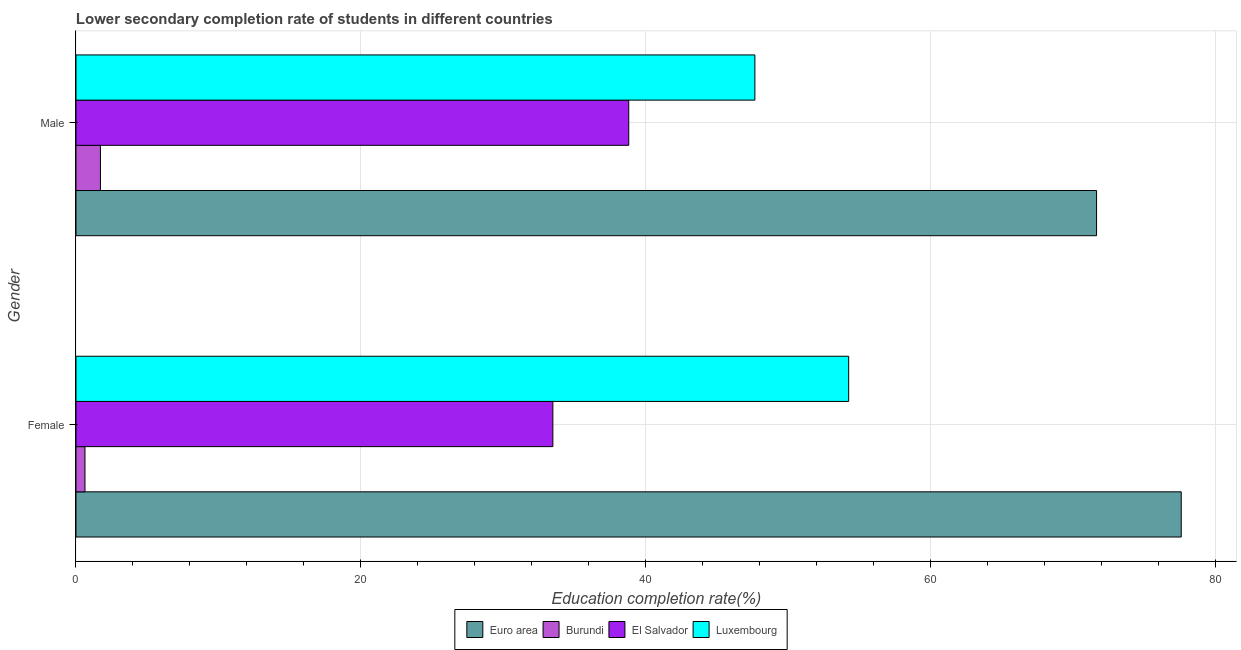How many different coloured bars are there?
Keep it short and to the point. 4. How many groups of bars are there?
Ensure brevity in your answer.  2. Are the number of bars on each tick of the Y-axis equal?
Your answer should be very brief. Yes. How many bars are there on the 2nd tick from the top?
Your answer should be very brief. 4. How many bars are there on the 2nd tick from the bottom?
Your answer should be compact. 4. What is the label of the 1st group of bars from the top?
Offer a terse response. Male. What is the education completion rate of male students in Burundi?
Ensure brevity in your answer.  1.72. Across all countries, what is the maximum education completion rate of male students?
Provide a succinct answer. 71.68. Across all countries, what is the minimum education completion rate of male students?
Offer a terse response. 1.72. In which country was the education completion rate of male students maximum?
Offer a terse response. Euro area. In which country was the education completion rate of male students minimum?
Your response must be concise. Burundi. What is the total education completion rate of male students in the graph?
Offer a terse response. 159.9. What is the difference between the education completion rate of male students in Burundi and that in Luxembourg?
Offer a very short reply. -45.96. What is the difference between the education completion rate of female students in Luxembourg and the education completion rate of male students in Burundi?
Provide a short and direct response. 52.55. What is the average education completion rate of male students per country?
Keep it short and to the point. 39.97. What is the difference between the education completion rate of male students and education completion rate of female students in Euro area?
Make the answer very short. -5.95. In how many countries, is the education completion rate of male students greater than 60 %?
Your response must be concise. 1. What is the ratio of the education completion rate of male students in Luxembourg to that in Euro area?
Your response must be concise. 0.67. What does the 1st bar from the bottom in Female represents?
Make the answer very short. Euro area. Are all the bars in the graph horizontal?
Provide a short and direct response. Yes. Does the graph contain any zero values?
Offer a very short reply. No. Where does the legend appear in the graph?
Ensure brevity in your answer.  Bottom center. What is the title of the graph?
Give a very brief answer. Lower secondary completion rate of students in different countries. What is the label or title of the X-axis?
Offer a very short reply. Education completion rate(%). What is the label or title of the Y-axis?
Provide a short and direct response. Gender. What is the Education completion rate(%) in Euro area in Female?
Provide a short and direct response. 77.63. What is the Education completion rate(%) of Burundi in Female?
Your answer should be compact. 0.63. What is the Education completion rate(%) in El Salvador in Female?
Your answer should be compact. 33.49. What is the Education completion rate(%) in Luxembourg in Female?
Keep it short and to the point. 54.27. What is the Education completion rate(%) of Euro area in Male?
Keep it short and to the point. 71.68. What is the Education completion rate(%) in Burundi in Male?
Provide a succinct answer. 1.72. What is the Education completion rate(%) of El Salvador in Male?
Ensure brevity in your answer.  38.82. What is the Education completion rate(%) of Luxembourg in Male?
Your answer should be compact. 47.68. Across all Gender, what is the maximum Education completion rate(%) of Euro area?
Your answer should be very brief. 77.63. Across all Gender, what is the maximum Education completion rate(%) of Burundi?
Your response must be concise. 1.72. Across all Gender, what is the maximum Education completion rate(%) of El Salvador?
Your answer should be compact. 38.82. Across all Gender, what is the maximum Education completion rate(%) of Luxembourg?
Your answer should be very brief. 54.27. Across all Gender, what is the minimum Education completion rate(%) in Euro area?
Provide a short and direct response. 71.68. Across all Gender, what is the minimum Education completion rate(%) in Burundi?
Provide a short and direct response. 0.63. Across all Gender, what is the minimum Education completion rate(%) of El Salvador?
Make the answer very short. 33.49. Across all Gender, what is the minimum Education completion rate(%) of Luxembourg?
Your response must be concise. 47.68. What is the total Education completion rate(%) in Euro area in the graph?
Your answer should be compact. 149.3. What is the total Education completion rate(%) in Burundi in the graph?
Provide a short and direct response. 2.35. What is the total Education completion rate(%) of El Salvador in the graph?
Give a very brief answer. 72.32. What is the total Education completion rate(%) of Luxembourg in the graph?
Keep it short and to the point. 101.95. What is the difference between the Education completion rate(%) of Euro area in Female and that in Male?
Ensure brevity in your answer.  5.95. What is the difference between the Education completion rate(%) of Burundi in Female and that in Male?
Your answer should be very brief. -1.09. What is the difference between the Education completion rate(%) of El Salvador in Female and that in Male?
Your answer should be very brief. -5.33. What is the difference between the Education completion rate(%) in Luxembourg in Female and that in Male?
Make the answer very short. 6.59. What is the difference between the Education completion rate(%) of Euro area in Female and the Education completion rate(%) of Burundi in Male?
Ensure brevity in your answer.  75.91. What is the difference between the Education completion rate(%) of Euro area in Female and the Education completion rate(%) of El Salvador in Male?
Offer a very short reply. 38.8. What is the difference between the Education completion rate(%) of Euro area in Female and the Education completion rate(%) of Luxembourg in Male?
Your answer should be very brief. 29.94. What is the difference between the Education completion rate(%) in Burundi in Female and the Education completion rate(%) in El Salvador in Male?
Offer a terse response. -38.19. What is the difference between the Education completion rate(%) in Burundi in Female and the Education completion rate(%) in Luxembourg in Male?
Make the answer very short. -47.05. What is the difference between the Education completion rate(%) in El Salvador in Female and the Education completion rate(%) in Luxembourg in Male?
Provide a short and direct response. -14.19. What is the average Education completion rate(%) of Euro area per Gender?
Make the answer very short. 74.65. What is the average Education completion rate(%) in Burundi per Gender?
Keep it short and to the point. 1.17. What is the average Education completion rate(%) in El Salvador per Gender?
Your answer should be compact. 36.16. What is the average Education completion rate(%) in Luxembourg per Gender?
Your answer should be compact. 50.97. What is the difference between the Education completion rate(%) in Euro area and Education completion rate(%) in Burundi in Female?
Keep it short and to the point. 76.99. What is the difference between the Education completion rate(%) in Euro area and Education completion rate(%) in El Salvador in Female?
Your answer should be very brief. 44.13. What is the difference between the Education completion rate(%) in Euro area and Education completion rate(%) in Luxembourg in Female?
Offer a terse response. 23.36. What is the difference between the Education completion rate(%) in Burundi and Education completion rate(%) in El Salvador in Female?
Ensure brevity in your answer.  -32.86. What is the difference between the Education completion rate(%) of Burundi and Education completion rate(%) of Luxembourg in Female?
Provide a succinct answer. -53.64. What is the difference between the Education completion rate(%) of El Salvador and Education completion rate(%) of Luxembourg in Female?
Ensure brevity in your answer.  -20.78. What is the difference between the Education completion rate(%) in Euro area and Education completion rate(%) in Burundi in Male?
Give a very brief answer. 69.96. What is the difference between the Education completion rate(%) of Euro area and Education completion rate(%) of El Salvador in Male?
Your answer should be compact. 32.86. What is the difference between the Education completion rate(%) of Euro area and Education completion rate(%) of Luxembourg in Male?
Keep it short and to the point. 24. What is the difference between the Education completion rate(%) of Burundi and Education completion rate(%) of El Salvador in Male?
Offer a terse response. -37.11. What is the difference between the Education completion rate(%) of Burundi and Education completion rate(%) of Luxembourg in Male?
Ensure brevity in your answer.  -45.96. What is the difference between the Education completion rate(%) in El Salvador and Education completion rate(%) in Luxembourg in Male?
Provide a short and direct response. -8.86. What is the ratio of the Education completion rate(%) in Euro area in Female to that in Male?
Ensure brevity in your answer.  1.08. What is the ratio of the Education completion rate(%) in Burundi in Female to that in Male?
Provide a short and direct response. 0.37. What is the ratio of the Education completion rate(%) of El Salvador in Female to that in Male?
Provide a succinct answer. 0.86. What is the ratio of the Education completion rate(%) in Luxembourg in Female to that in Male?
Provide a short and direct response. 1.14. What is the difference between the highest and the second highest Education completion rate(%) of Euro area?
Your answer should be very brief. 5.95. What is the difference between the highest and the second highest Education completion rate(%) of Burundi?
Offer a terse response. 1.09. What is the difference between the highest and the second highest Education completion rate(%) of El Salvador?
Provide a short and direct response. 5.33. What is the difference between the highest and the second highest Education completion rate(%) in Luxembourg?
Provide a succinct answer. 6.59. What is the difference between the highest and the lowest Education completion rate(%) in Euro area?
Keep it short and to the point. 5.95. What is the difference between the highest and the lowest Education completion rate(%) in Burundi?
Provide a succinct answer. 1.09. What is the difference between the highest and the lowest Education completion rate(%) of El Salvador?
Provide a succinct answer. 5.33. What is the difference between the highest and the lowest Education completion rate(%) in Luxembourg?
Ensure brevity in your answer.  6.59. 